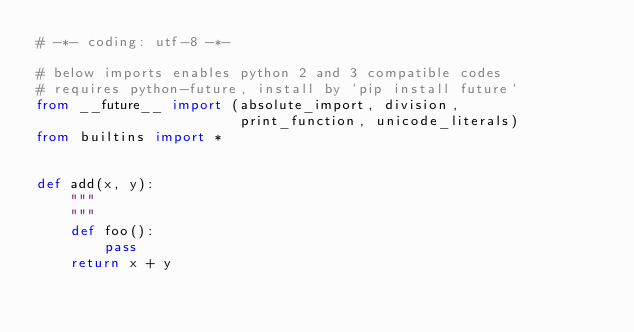Convert code to text. <code><loc_0><loc_0><loc_500><loc_500><_Python_># -*- coding: utf-8 -*-

# below imports enables python 2 and 3 compatible codes
# requires python-future, install by `pip install future`
from __future__ import (absolute_import, division,
                        print_function, unicode_literals)
from builtins import *


def add(x, y):
    """
    """
    def foo():
        pass
    return x + y
</code> 